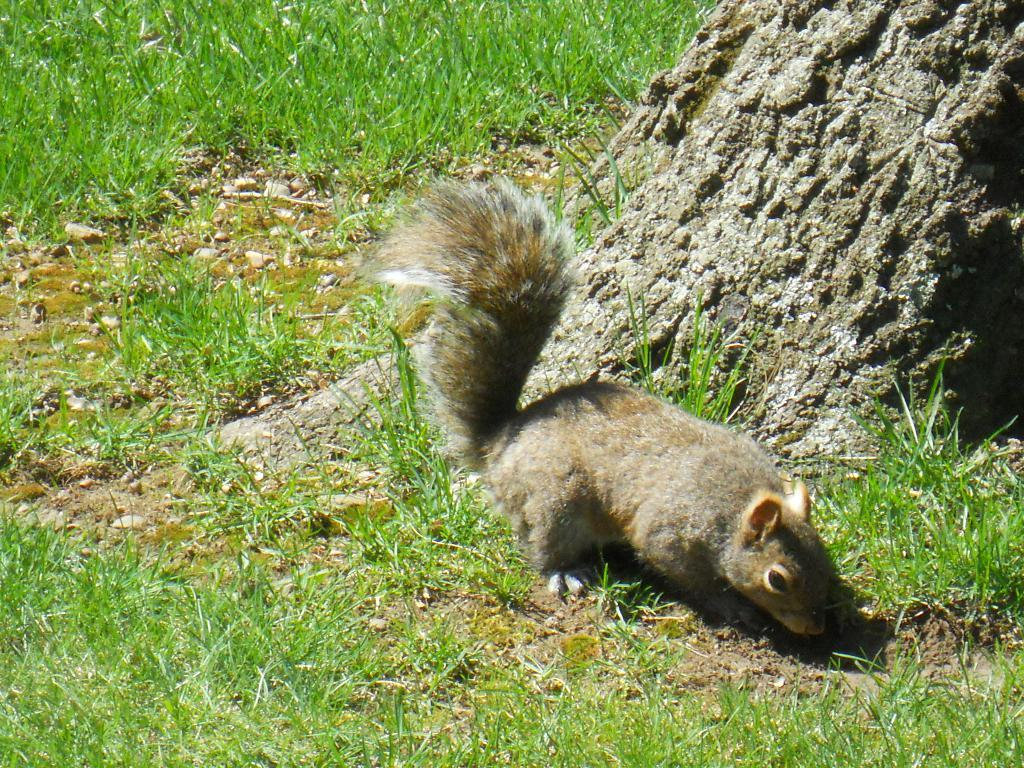What type of vegetation is visible in the foreground of the picture? There is grass and soil in the foreground of the picture. What other objects can be seen in the foreground of the picture? There are stones and a squirrel in the foreground of the picture. What part of a tree is visible in the foreground of the picture? The trunk of a tree is visible in the foreground of the picture. What type of vegetation is visible at the top of the picture? There is grass at the top of the picture. How many cents are visible on the squirrel in the image? There are no cents visible on the squirrel in the image, as it is a living creature and not a currency. What type of carriage can be seen transporting the tree trunk in the image? There is no carriage present in the image; the tree trunk is in the foreground without any transportation. 